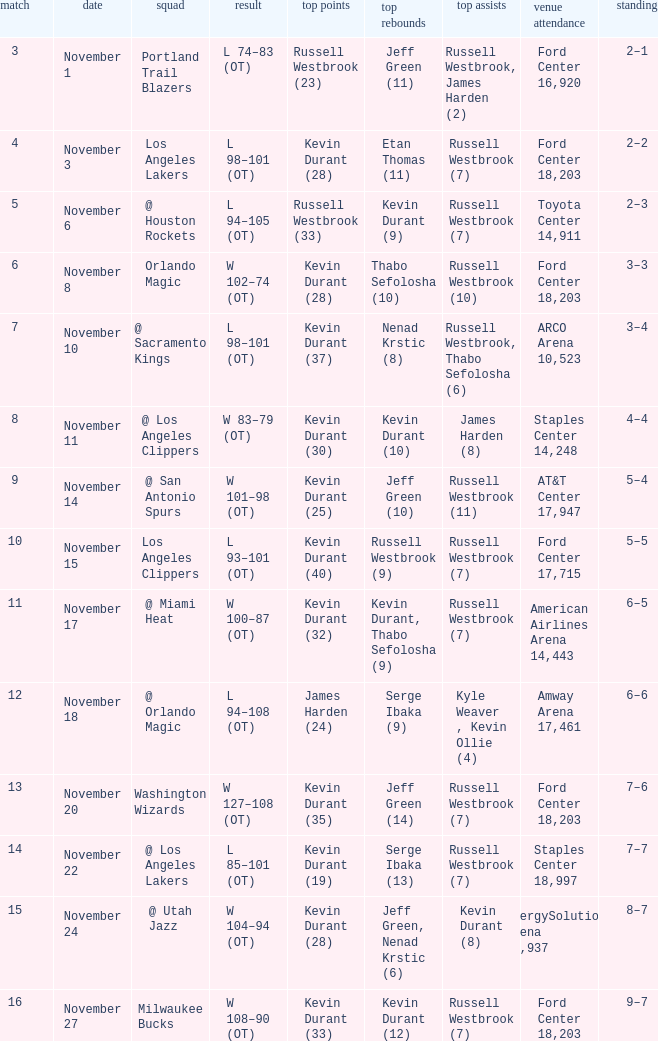Where was the game in which Kevin Durant (25) did the most high points played? AT&T Center 17,947. 